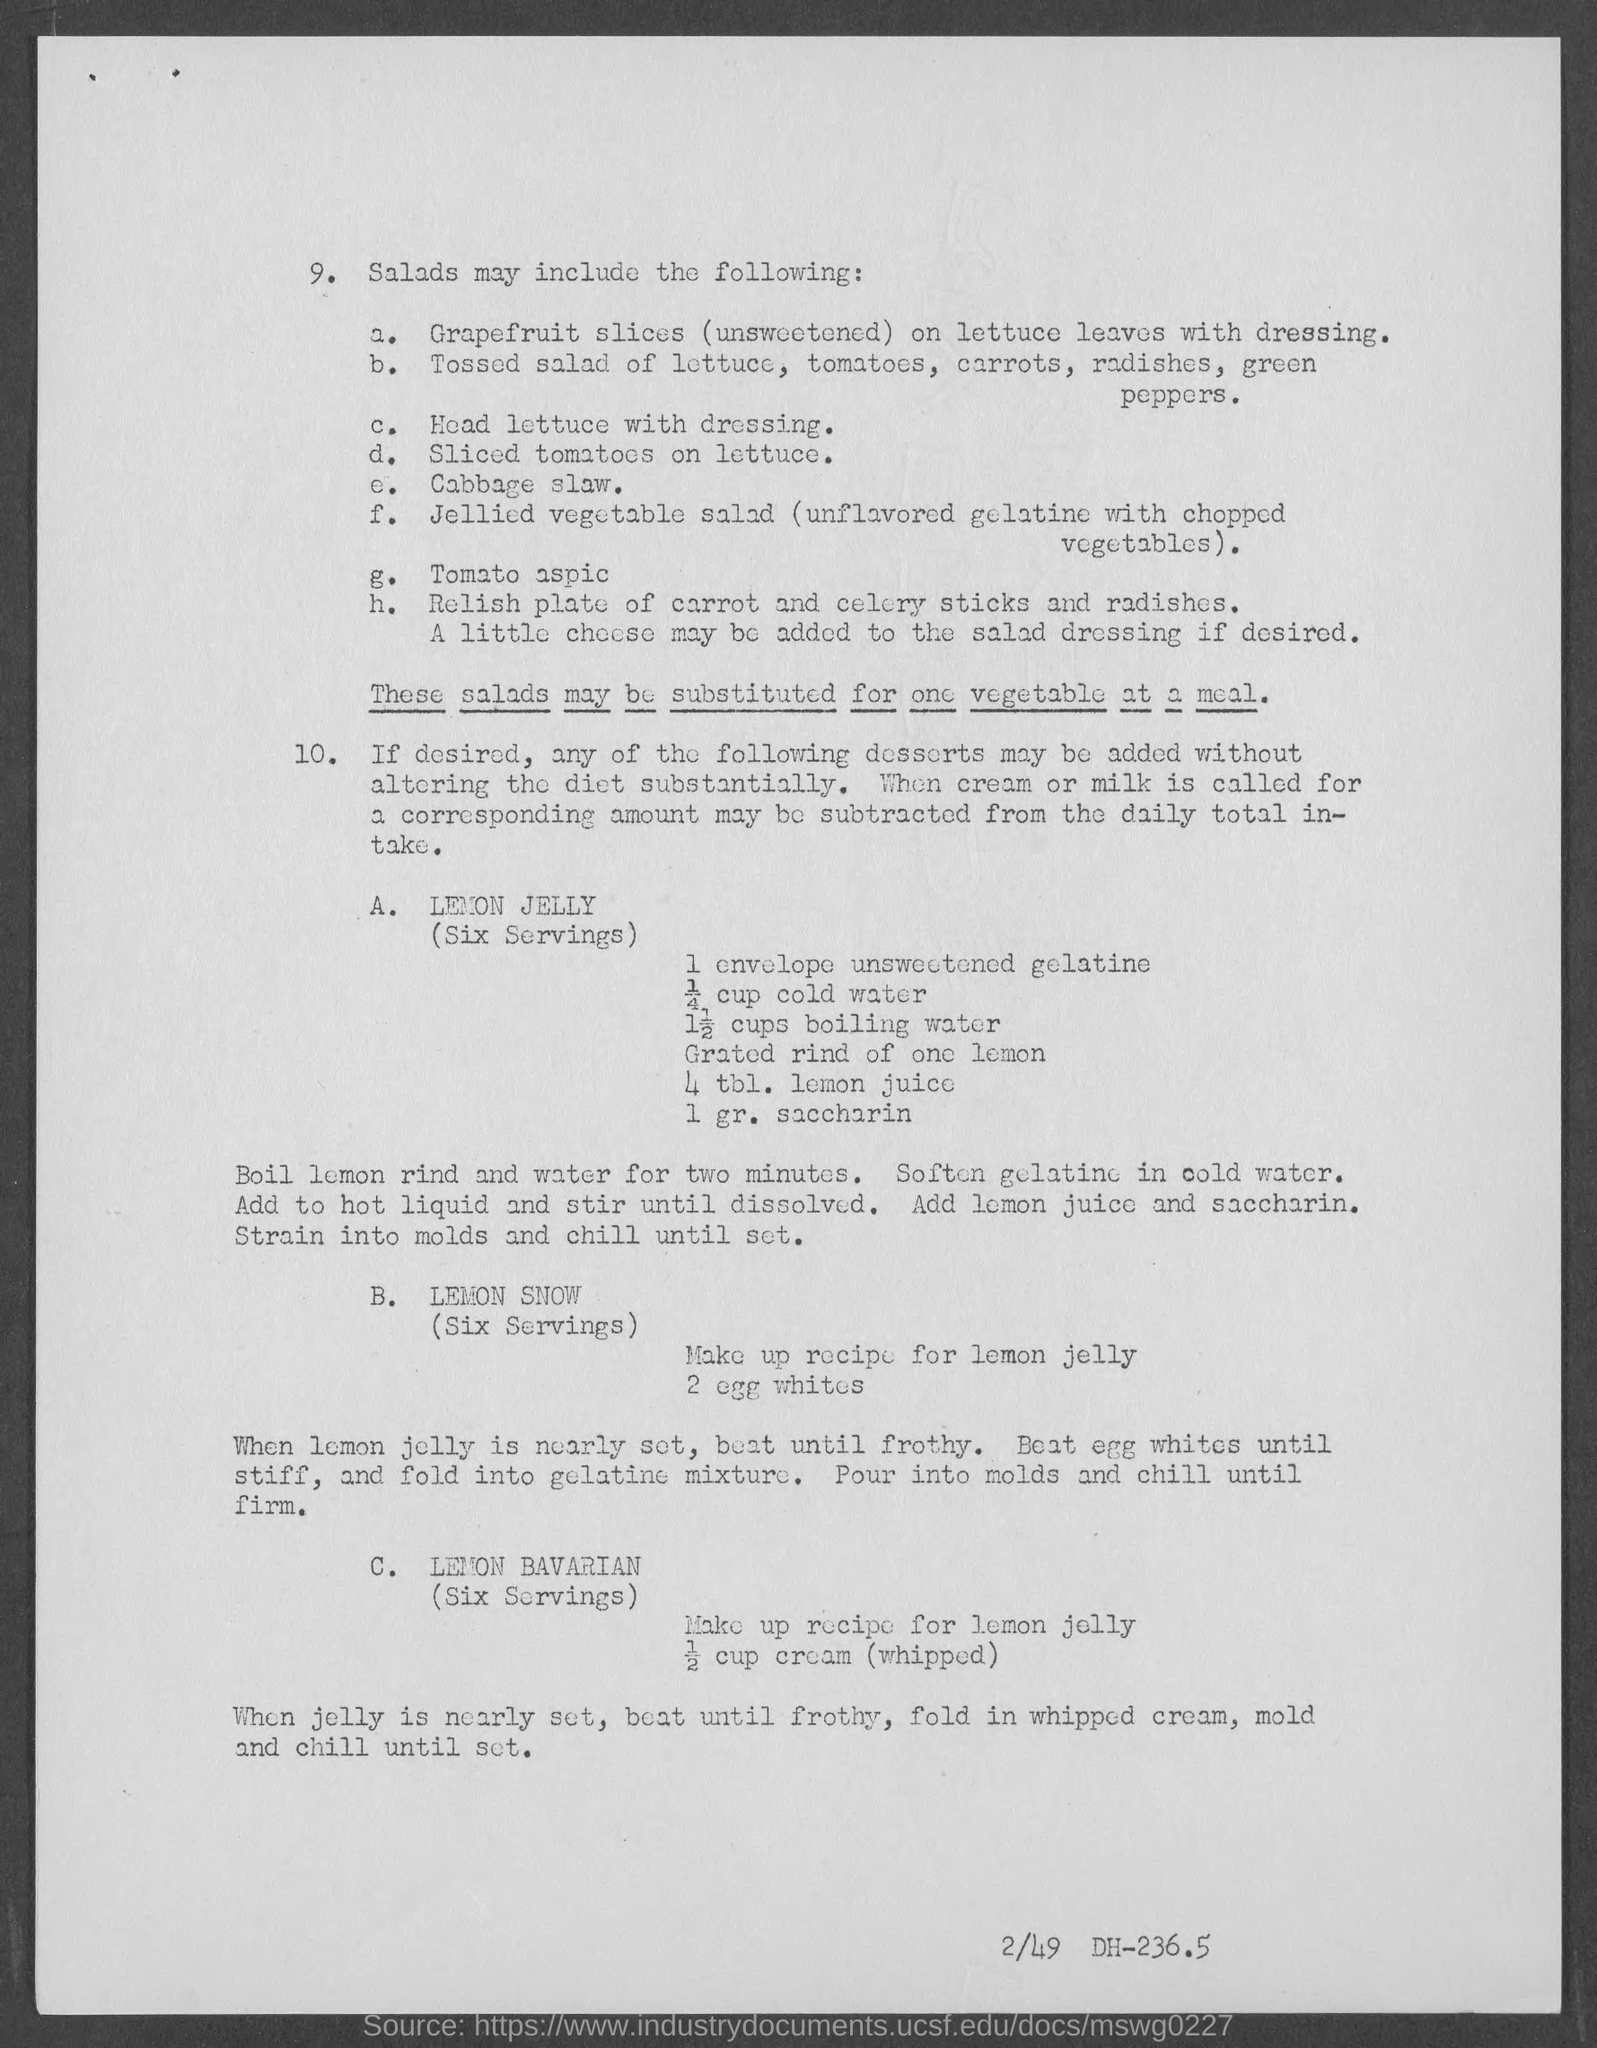Give some essential details in this illustration. The item "c", which may be included in making salads, is head lettuce. It is commonly used in conjunction with dressing to create a delicious and refreshing salad. The dessert named "lemon jelly" is listed under the category of "10" and is referred to as "A". Item e, cabbage slaw, may be included in the making of salads. It is necessary to replace these salads with a vegetable dish at a meal. The item 'g,' which may be used in making salads, is tomato aspic. 